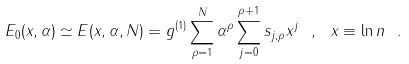<formula> <loc_0><loc_0><loc_500><loc_500>E _ { 0 } ( x , \alpha ) \simeq E ( x , \alpha , N ) = g ^ { ( 1 ) } \sum _ { \rho = 1 } ^ { N } \alpha ^ { \rho } \sum _ { j = 0 } ^ { \rho + 1 } s _ { j , \rho } x ^ { j } \ , \ x \equiv \ln n \ .</formula> 